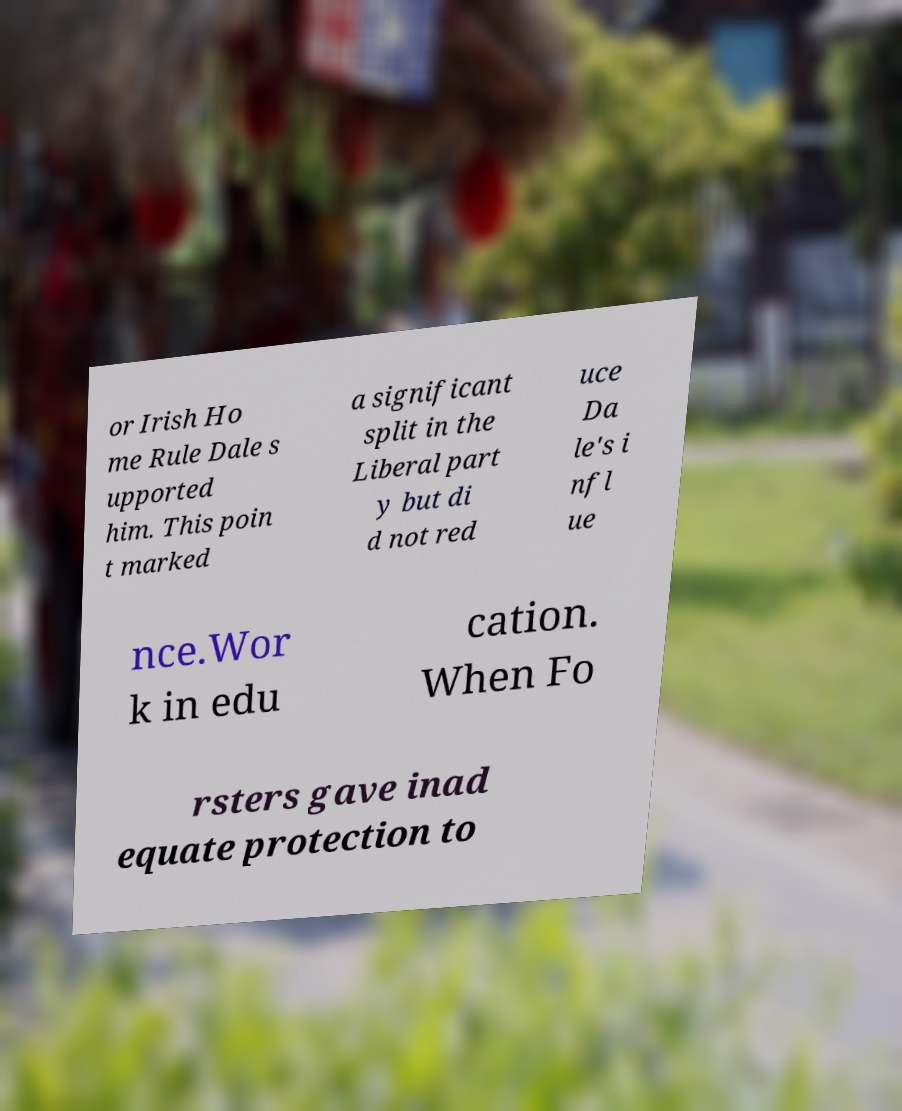Can you read and provide the text displayed in the image?This photo seems to have some interesting text. Can you extract and type it out for me? or Irish Ho me Rule Dale s upported him. This poin t marked a significant split in the Liberal part y but di d not red uce Da le's i nfl ue nce.Wor k in edu cation. When Fo rsters gave inad equate protection to 